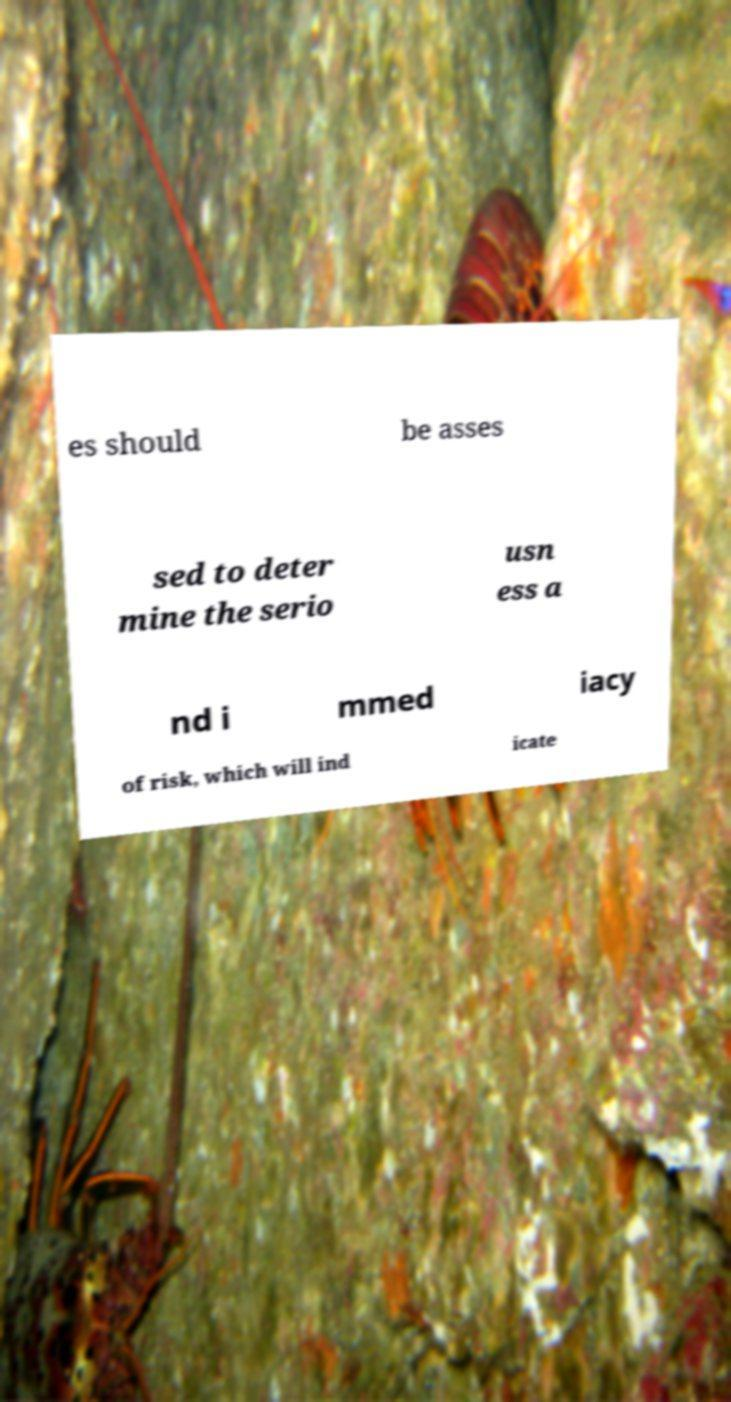Please identify and transcribe the text found in this image. es should be asses sed to deter mine the serio usn ess a nd i mmed iacy of risk, which will ind icate 